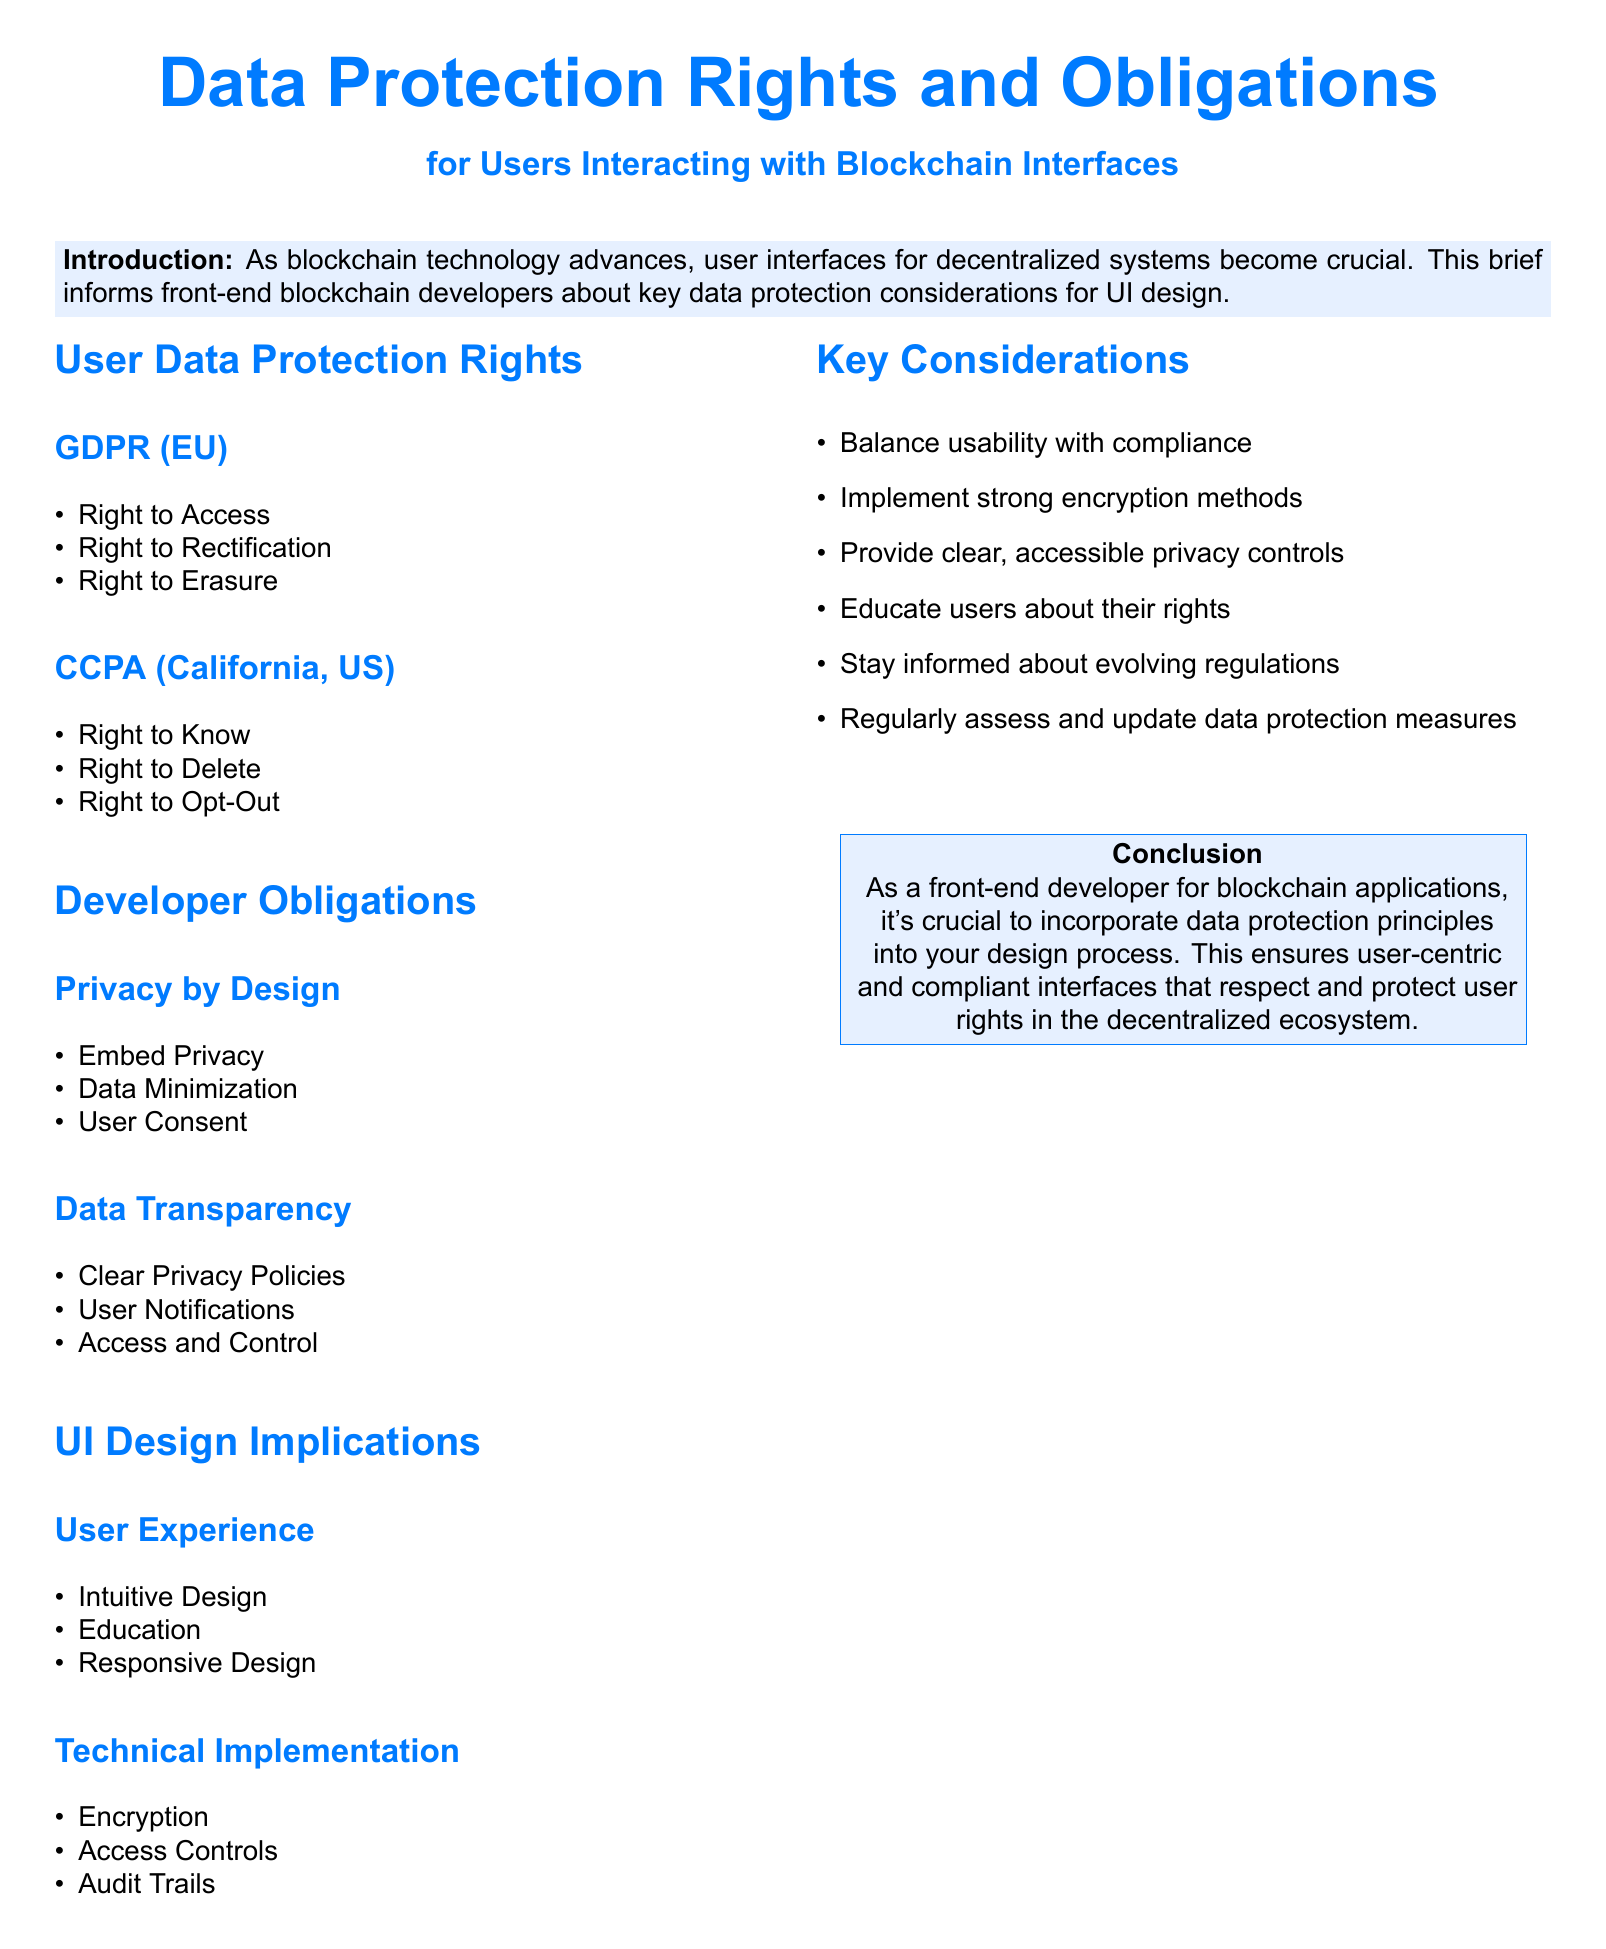what is the title of the document? The title is presented at the beginning of the document, indicating the subject matter.
Answer: Data Protection Rights and Obligations how many user data protection rights are mentioned in GDPR? The document lists the rights under GDPR, providing a specific number for quick reference.
Answer: 3 what is the right to delete associated with? The right to delete is specifically listed under CCPA regulations guiding data protection rights in California.
Answer: CCPA name one obligation of developers regarding data protection. The document provides a list of developer obligations focusing on key principles for compliance.
Answer: Privacy by Design what does "Privacy by Design" emphasize? This section highlights the fundamental principles developers should incorporate into their designs.
Answer: Embed Privacy how many sections are there in the Developer Obligations part? The Developer Obligations section contains specific subsections outlining key considerations for developers.
Answer: 2 what is important for user experience in UI design? This aspect focuses on the elements crucial for creating a user-friendly interface in blockchain applications.
Answer: Intuitive Design what is one key consideration for blockchain developers? The document outlines essential factors that developers should keep in mind while ensuring compliance.
Answer: Balance usability with compliance how should developers approach user education? This aspect emphasizes an essential component for enhancing user awareness of their rights and protections.
Answer: Education 